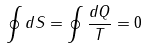Convert formula to latex. <formula><loc_0><loc_0><loc_500><loc_500>\oint d S = \oint \frac { d Q } { T } = 0</formula> 